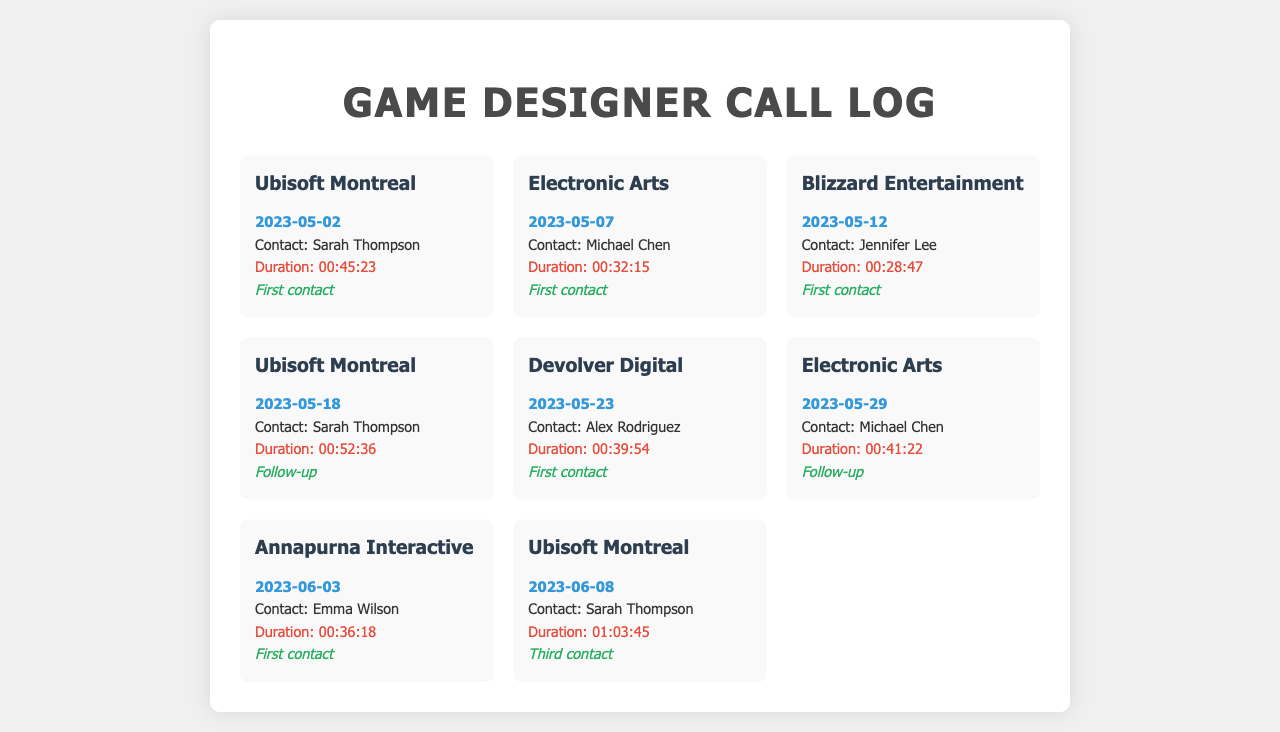What is the duration of the call with Ubisoft Montreal on May 2, 2023? The duration of the call is indicated in the document for the specific date and company, which is 00:45:23.
Answer: 00:45:23 Who was the contact person for Blizzard Entertainment? The contact person is listed in the document for Blizzard Entertainment, which is Jennifer Lee.
Answer: Jennifer Lee What type of call was made to Electronic Arts on May 29, 2023? The type of call is described in the document as a follow-up for that particular date and company.
Answer: Follow-up How many times did the designer contact Ubisoft Montreal? The document lists three separate calls made to Ubisoft Montreal, indicated by "First contact," "Follow-up," and "Third contact."
Answer: Three times What was the duration of the call with Devolver Digital? The document specifies the duration of the call with Devolver Digital as 00:39:54.
Answer: 00:39:54 On what date was the second call to Electronic Arts made? The date of the second call to Electronic Arts, as reflected in the document, is 2023-05-29.
Answer: 2023-05-29 What is the frequency of the call made on June 8 to Ubisoft Montreal? The frequency is noted in the document as the "Third contact" for that date and company.
Answer: Third contact Who was the contact person during the call with Annapurna Interactive? The name of the contact person for Annapurna Interactive is provided in the document, which is Emma Wilson.
Answer: Emma Wilson 